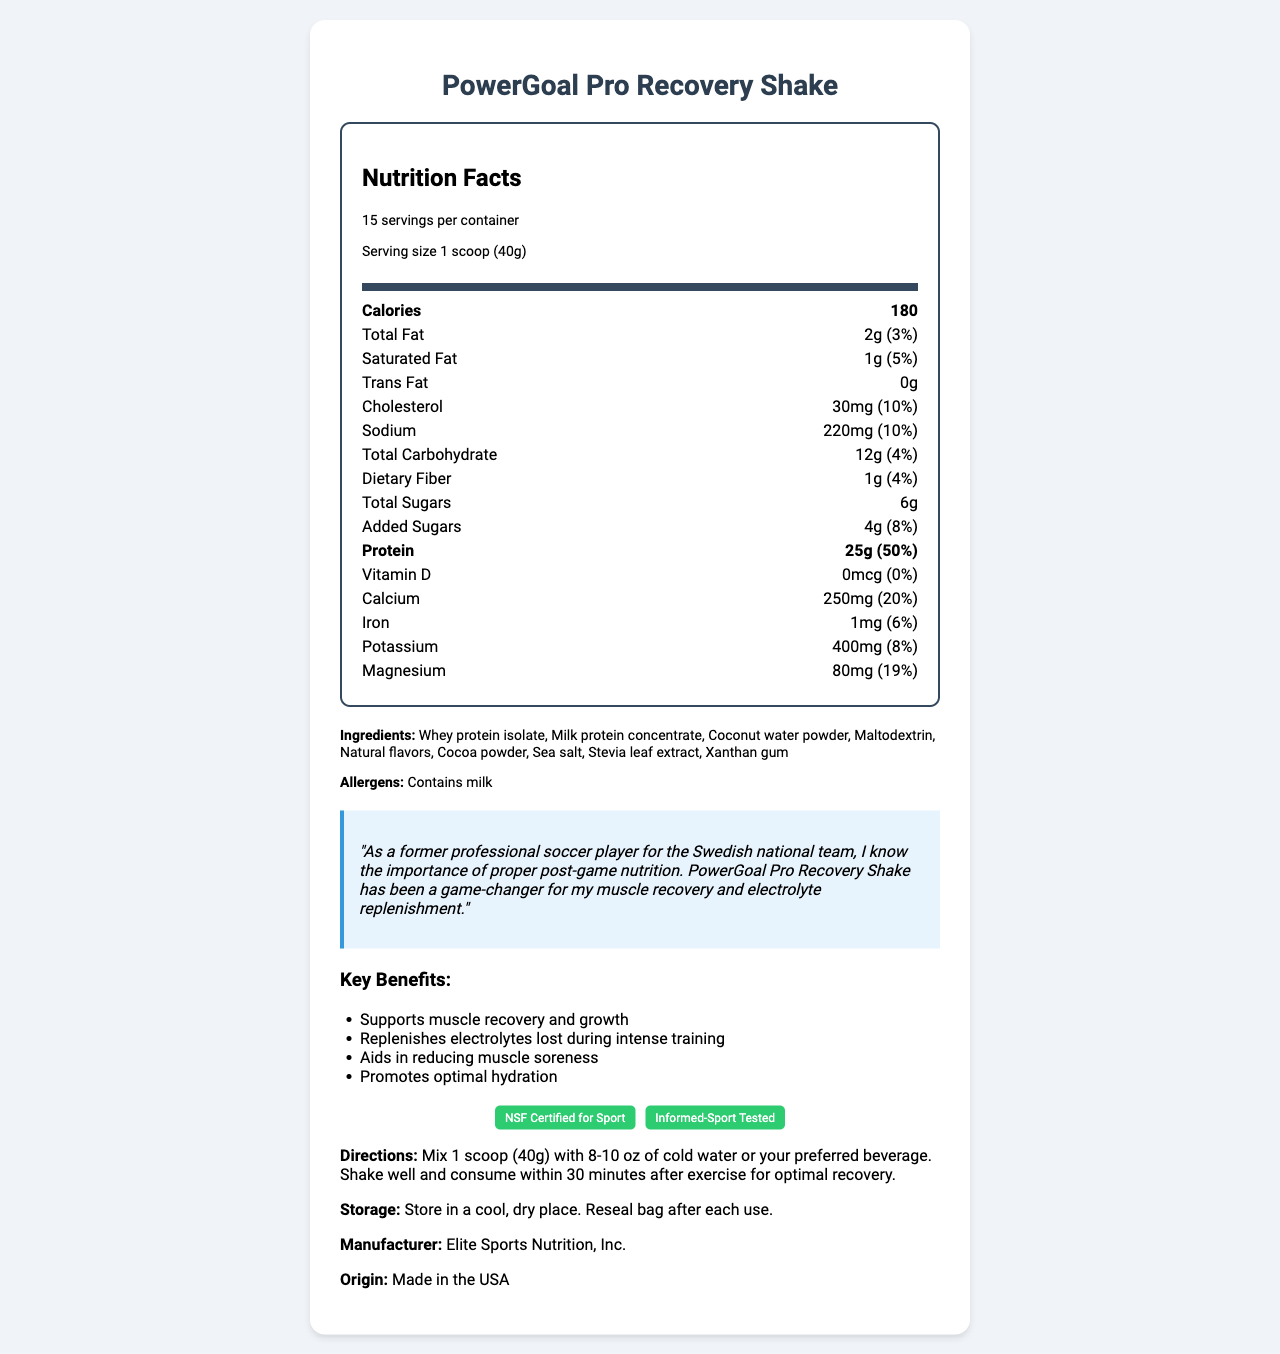what is the serving size? The serving size is mentioned right at the beginning under the "serving-info" section of the document.
Answer: 1 scoop (40g) how many servings are there per container? The "servings_per_container" is listed as 15.
Answer: 15 how much protein does each serving contain? The amount of protein per serving is listed under the nutrition facts section, marked as 25g with a daily value of 50%.
Answer: 25g what is the daily value percentage of calcium per serving? The percentage value of calcium is provided in the nutrition facts, listed as 20%.
Answer: 20% which ingredient is an allergen? Under the allergens section, it states that the shake contains milk.
Answer: Milk what is the sodium content per serving? The amount of sodium per serving is listed as 220mg.
Answer: 220mg how many grams of total sugars are there per serving? The total sugars per serving is listed in the nutrition facts as 6g.
Answer: 6g what is the daily value percentage of saturated fat in each serving? A. 3% B. 5% C. 10% D. 20% Under the nutrition facts, it shows that the saturated fat contributes 5% to the daily value.
Answer: B. 5% how much dietary fiber is there per serving? A. 0g B. 1g C. 2g D. 4g The dietary fiber per serving is listed as 1g, contributing 4% to the daily value.
Answer: B. 1g is there any vitamin D in this shake? The nutrition label shows that vitamin D is 0mcg, which is 0% of the daily value.
Answer: No is this recovery shake beneficial for electrolyte replenishment? The document mentions that the shake helps in replenishing electrolytes lost during intense training.
Answer: Yes summarize the key benefits of the PowerGoal Pro Recovery Shake The key benefits section lists these four main advantages of the product.
Answer: Supports muscle recovery and growth, replenishes electrolytes lost during intense training, aids in reducing muscle soreness, promotes optimal hydration what certifications does this product have? The certifications are clearly listed at the bottom of the document.
Answer: NSF Certified for Sport, Informed-Sport Tested describe how to prepare and consume this recovery shake The directions provide a clear step-by-step guide on how to prepare and when to consume the shake.
Answer: Mix 1 scoop (40g) with 8-10 oz of cold water or your preferred beverage. Shake well and consume within 30 minutes after exercise for optimal recovery. how does the athlete testimonial describe the benefits of the PowerGoal Pro Recovery Shake? The testimonial claims that the shake significantly improved muscle recovery and electrolyte replenishment.
Answer: It has been a game-changer for muscle recovery and electrolyte replenishment. who is the manufacturer of this product? The manufacturer’s information is listed at the end of the document.
Answer: Elite Sports Nutrition, Inc. where was this product made? The origin of the product is provided at the end of the document.
Answer: Made in the USA how much cholesterol is there per serving? The amount of cholesterol per serving is listed as 30mg in the nutrition facts.
Answer: 30mg what country did the athlete who gave the testimonial play for? The testimonial mentions that the athlete was a former professional soccer player for the Swedish national team.
Answer: Sweden what is the athlete's full name who gave the testimonial? The document doesn't mention the full name of the athlete, only that they were a former professional soccer player for the Swedish national team.
Answer: Cannot be determined 